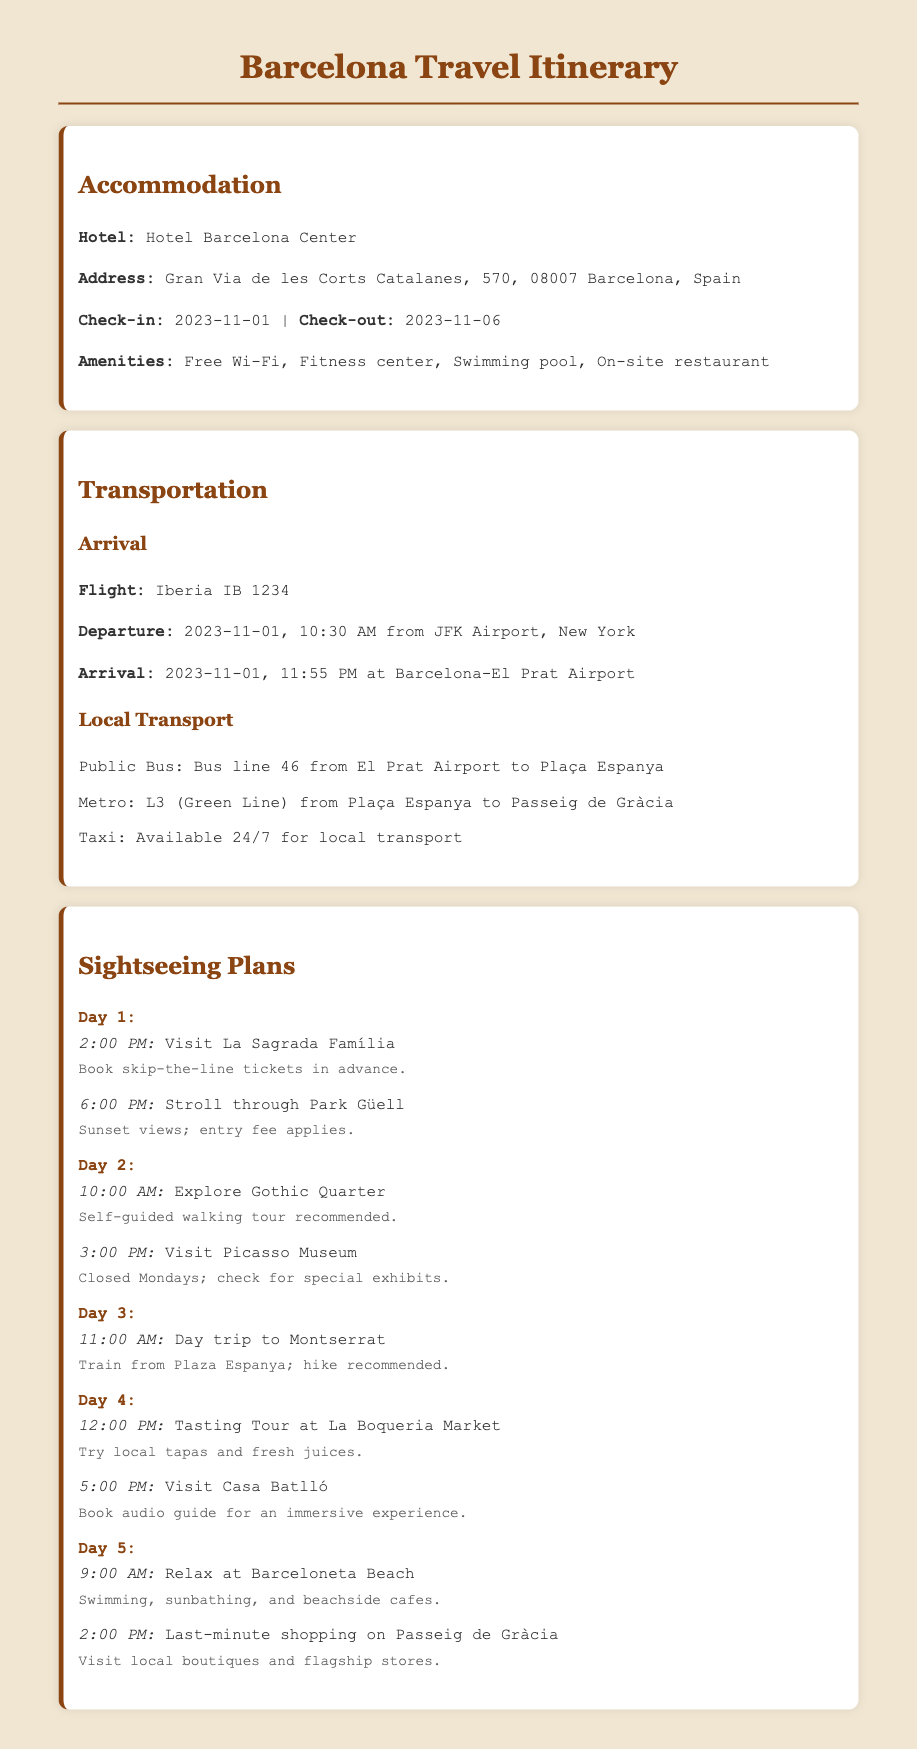What is the check-in date? The check-in date is specified in the accommodation section as the beginning date of the stay at the hotel.
Answer: 2023-11-01 What is the name of the hotel? The document provides the name of the hotel where the traveler will be staying, which is mentioned under accommodation.
Answer: Hotel Barcelona Center What flight will be taken for arrival? The flight details are listed in the transportation section under arrival, specifying the flight number for the trip.
Answer: Iberia IB 1234 When will the traveler visit La Sagrada Família? The document provides a specific time for visiting La Sagrada Família in the sightseeing plans.
Answer: 2:00 PM What local transport method is mentioned for traveling from the airport to Plaça Espanya? The transportation section lists different means of local transport, providing information specifically on bus service.
Answer: Bus line 46 How many days is the trip planned for? The duration of the trip can be inferred from the check-in and check-out dates provided in the accommodation section.
Answer: 5 days Which day includes a visit to the Picasso Museum? The sightseeing plans outline which day involves visiting the Picasso Museum, digging into the scheduled activities by day.
Answer: Day 2 What is recommended to try at La Boqueria Market? The document mentions specific local delicacies suggested during the tasting tour at La Boqueria Market.
Answer: Local tapas and fresh juices What activity is suggested for Day 3? The itinerary specifies the main planned activity for Day 3, which includes a particular trip.
Answer: Day trip to Montserrat 